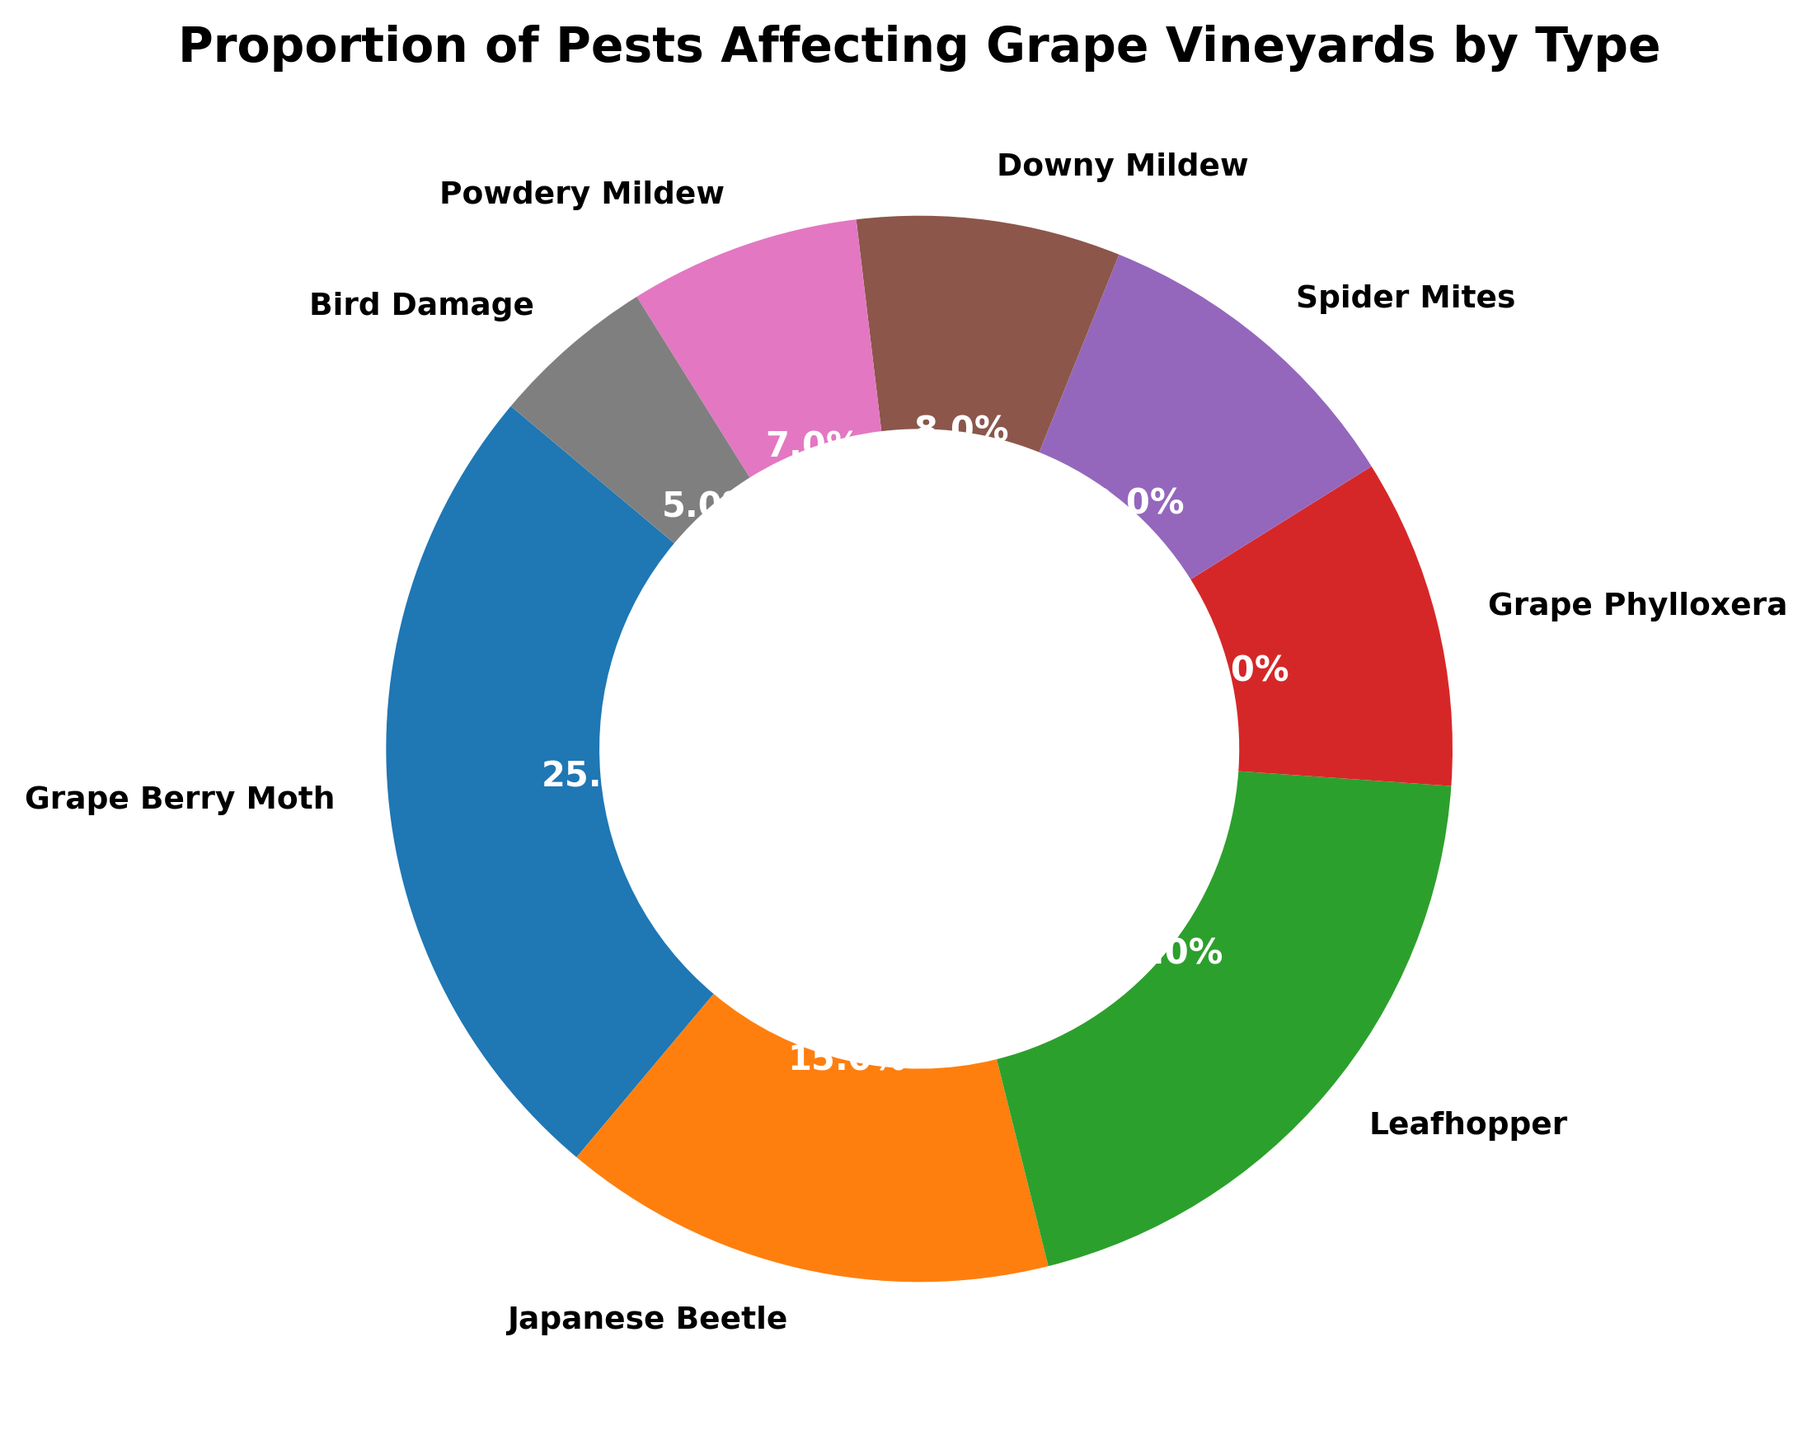What's the most common pest affecting grape vineyards? The ring chart shows that Grape Berry Moth has the largest proportion, taking up 25% of the chart. This indicates it is the most common pest.
Answer: Grape Berry Moth Which pest has the smallest proportion affecting grape vineyards? Bird Damage has the smallest proportion, taking up 5% of the ring chart, indicating it is the least common pest.
Answer: Bird Damage What is the combined proportion of Leafhopper and Grape Phylloxera? Leafhopper represents 20% and Grape Phylloxera represents 10% of the chart. Adding these two percentages gives a total combined proportion of 30%.
Answer: 30% Is the proportion of Downy Mildew greater than Spider Mites? Downy Mildew makes up 8% of the chart, while Spider Mites make up 10%. Therefore, Downy Mildew's proportion is less than that of Spider Mites.
Answer: No Which three pests collectively make up 50% of the proportion? Grape Berry Moth (25%), Leafhopper (20%), and Japanese Beetle (15%) are the top three pests. Adding their proportions gives 25% + 20% + 15% = 60%. Since only the top two (Grape Berry Moth and Leafhopper, totaling 45%) do not make 50%, one more pest should be added. The next highest proportion is Japanese Beetle at 15%, but the sum is 60%, not 50%. None exactly make up 50%.
Answer: None What's the proportion difference between Japanese Beetle and Powdery Mildew? The proportion of Japanese Beetle is 15% and that of Powdery Mildew is 7%. Subtracting these values gives the difference, which is 15% - 7% = 8%.
Answer: 8% What proportion of the chart is occupied by pests other than Grape Berry Moth? Grape Berry Moth takes up 25% of the chart. The remaining proportion is 100% - 25% = 75%.
Answer: 75% Which two pests have the same proportion affecting grape vineyards? The ring chart shows that both Grape Phylloxera and Spider Mites each make up 10% of the chart.
Answer: Grape Phylloxera and Spider Mites What is the average proportion of Downy Mildew and Powdery Mildew? Downy Mildew has an 8% proportion and Powdery Mildew has a 7% proportion. The average is calculated by (8% + 7%) / 2 = 7.5%.
Answer: 7.5% Are there more pests with proportions greater than or equal to 10% than those below 10%? Pests with proportions ≥ 10% are Grape Berry Moth (25%), Japanese Beetle (15%), Leafhopper (20%), Grape Phylloxera (10%), and Spider Mites (10%), totaling 5 pests. Pests with proportions < 10% are Downy Mildew (8%), Powdery Mildew (7%), and Bird Damage (5%), totaling 3 pests. Therefore, there are more pests with greater than or equal to 10% proportions.
Answer: Yes 